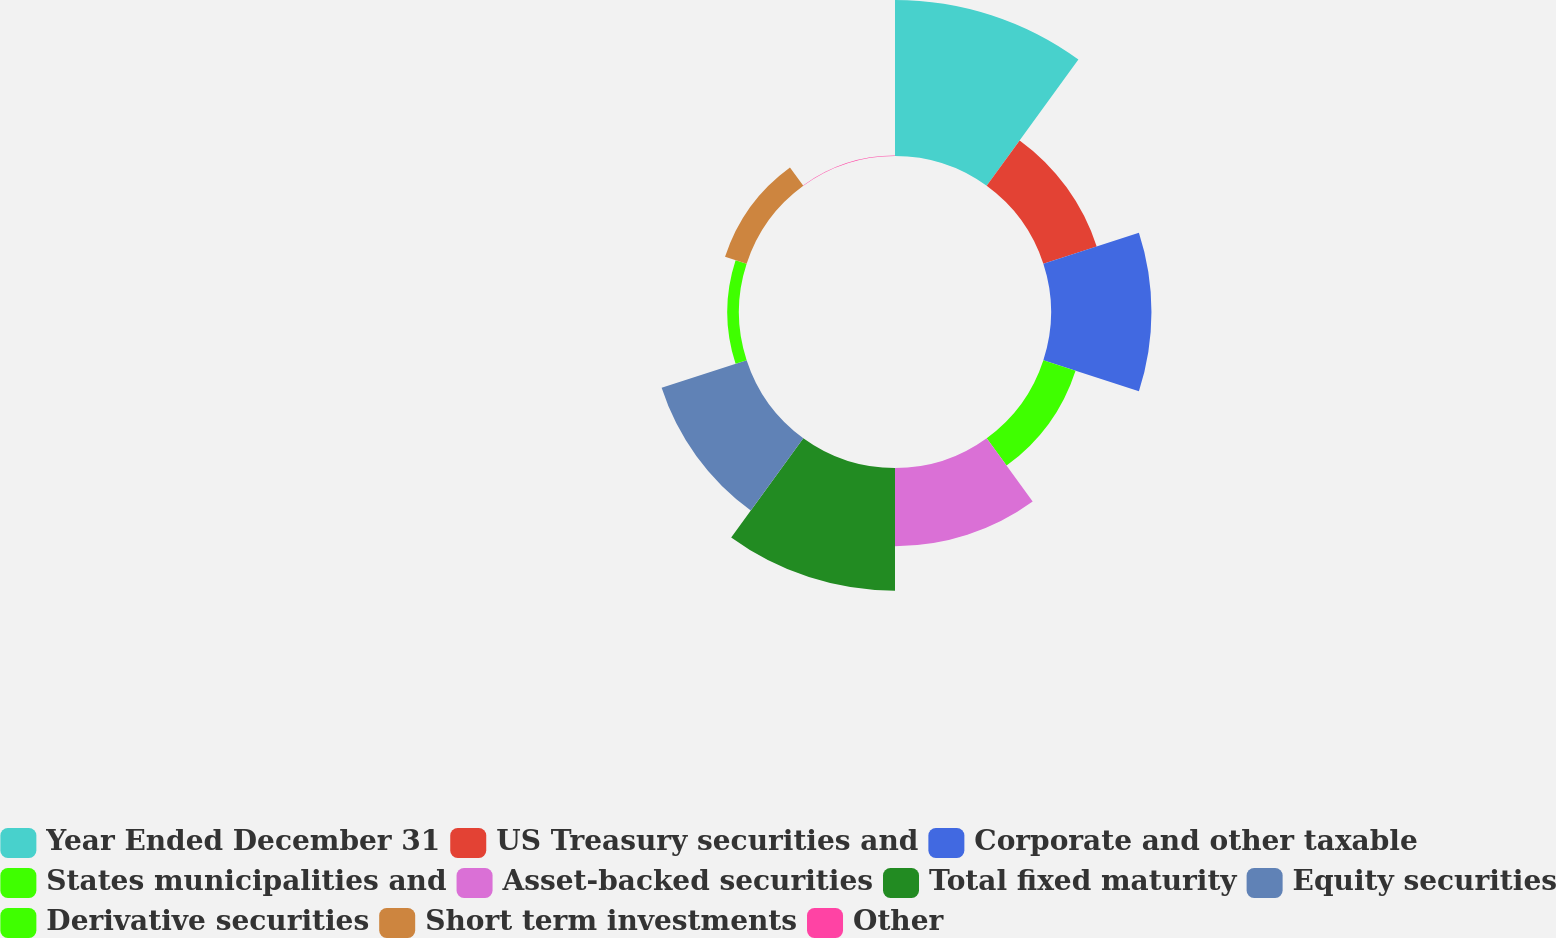Convert chart to OTSL. <chart><loc_0><loc_0><loc_500><loc_500><pie_chart><fcel>Year Ended December 31<fcel>US Treasury securities and<fcel>Corporate and other taxable<fcel>States municipalities and<fcel>Asset-backed securities<fcel>Total fixed maturity<fcel>Equity securities<fcel>Derivative securities<fcel>Short term investments<fcel>Other<nl><fcel>23.23%<fcel>8.35%<fcel>14.96%<fcel>5.04%<fcel>11.65%<fcel>18.27%<fcel>13.31%<fcel>1.73%<fcel>3.38%<fcel>0.07%<nl></chart> 